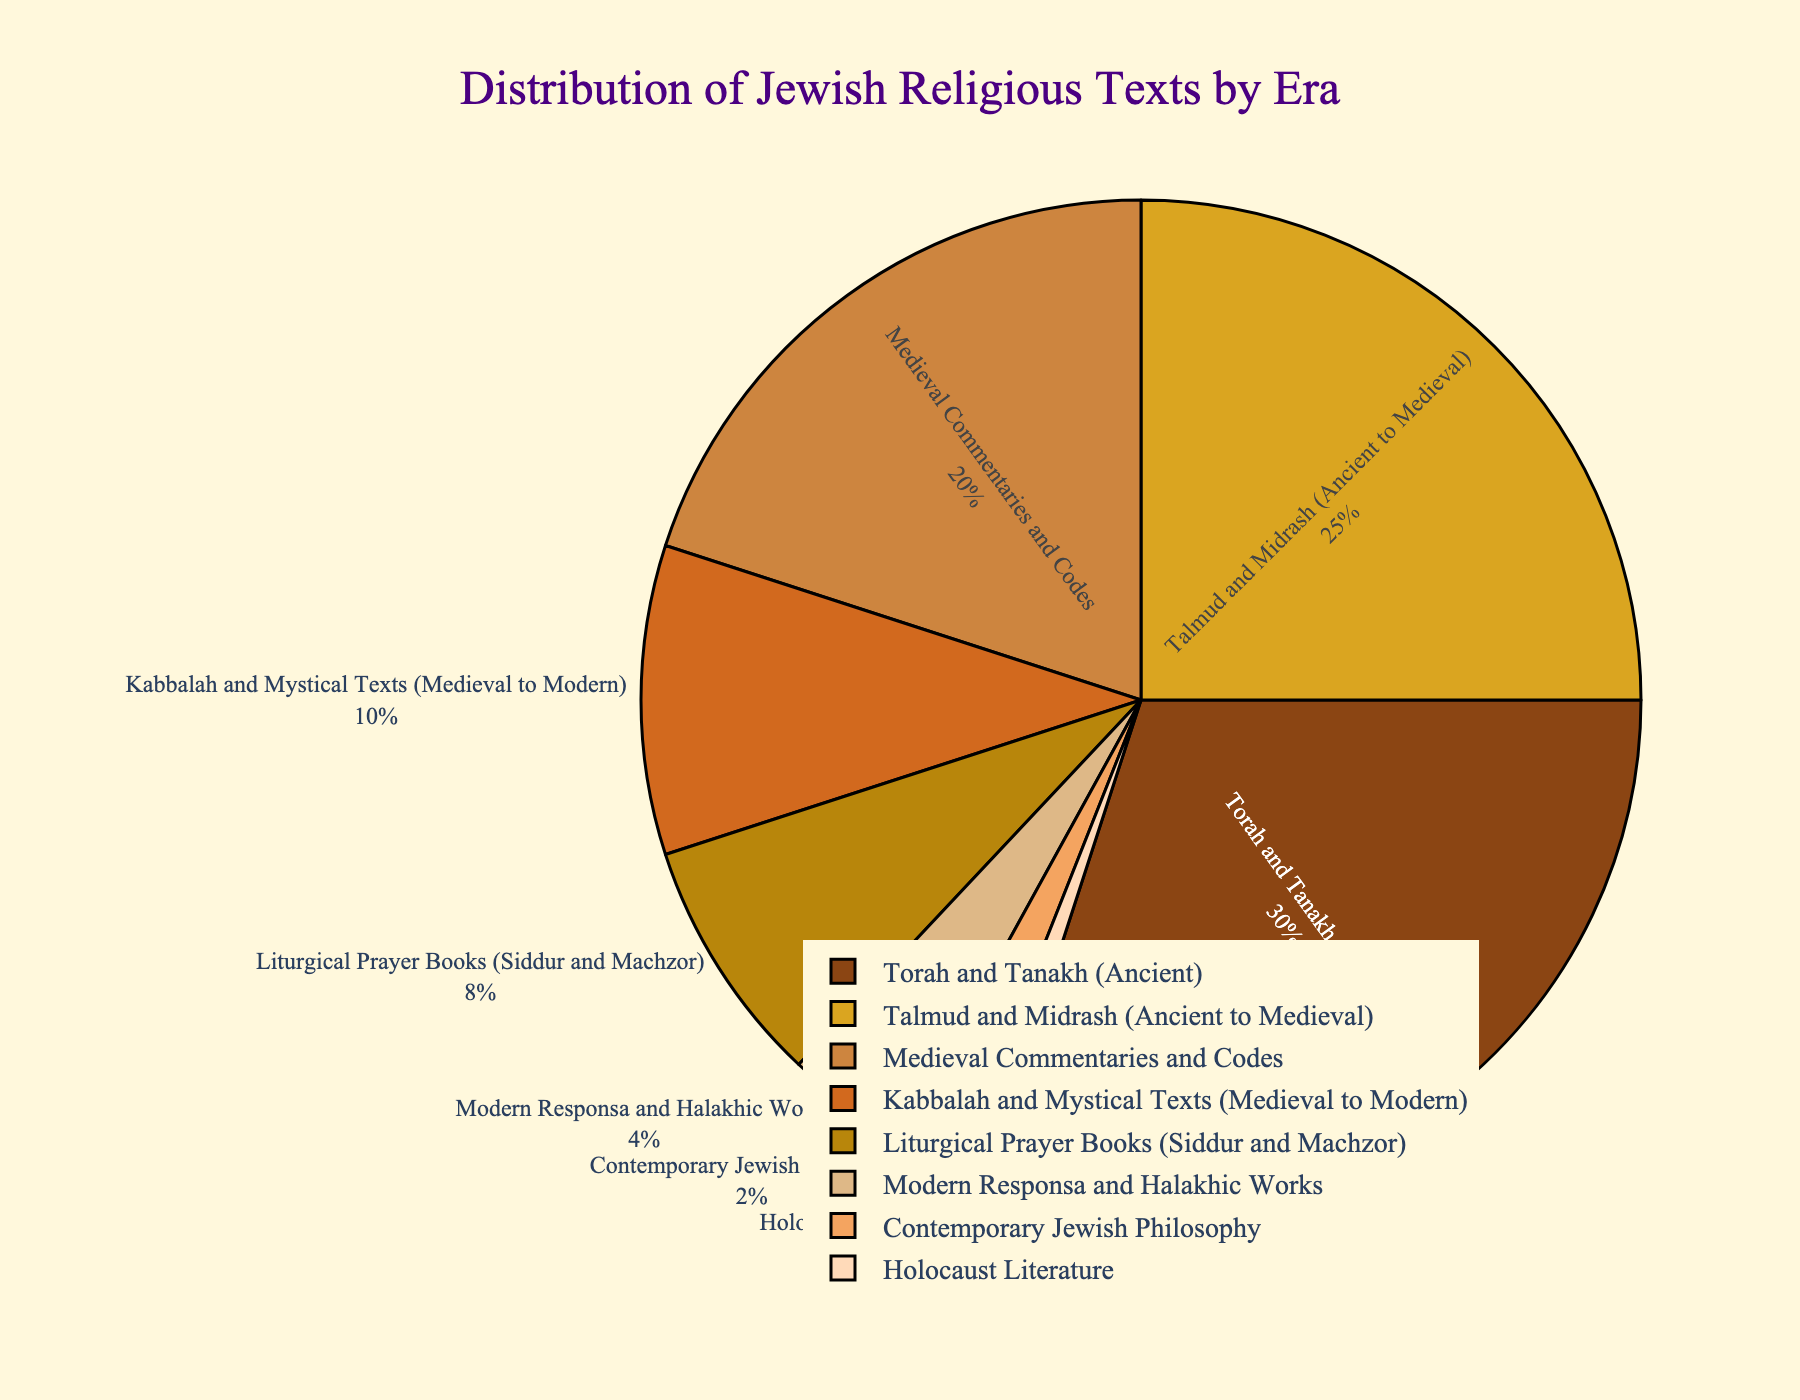Which era has the highest representation in the distribution? Look at the segment with the largest proportion in the pie chart, which is labeled as "Torah and Tanakh (Ancient)" having 30%.
Answer: Torah and Tanakh (Ancient) Which eras combined account for more than half of the distribution? Add the percentages of the largest segments one by one until the sum exceeds 50%. “Torah and Tanakh (Ancient)” is 30%, and “Talmud and Midrash (Ancient to Medieval)” is 25%. Their combined percentage is 30% + 25% = 55%.
Answer: Torah and Tanakh (Ancient) and Talmud and Midrash (Ancient to Medieval) Which era has the smallest representation in the distribution? Look at the segment with the smallest proportion in the pie chart, which is labeled "Holocaust Literature" having 1%.
Answer: Holocaust Literature What is the difference in the percentage of Medieval Commentaries and Codes compared to Modern Responsa and Halakhic Works? Find the percentage of both segments and subtract the smaller from the larger. Medieval Commentaries and Codes: 20%, Modern Responsa and Halakhic Works: 4%. Difference is 20% - 4% = 16%.
Answer: 16% Which combined percentage is higher: Kabbalah and Mystical Texts (Medieval to Modern) and Liturgical Prayer Books (Siddur and Machzor) or Modern Responsa and Halakhic Works and Contemporary Jewish Philosophy? Calculate the sums of both pairs: Kabbalah and Mystical Texts (10%) + Liturgical Prayer Books (8%) = 18%, and Modern Responsa and Halakhic Works (4%) + Contemporary Jewish Philosophy (2%) = 6%. Compare the totals, 18% is higher than 6%.
Answer: Kabbalah and Mystical Texts (Medieval to Modern) and Liturgical Prayer Books (Siddur and Machzor) Which era's segment color is the darkest brown? Visually identify the darkest brown segment in the pie chart, corresponding to the "Torah and Tanakh (Ancient)" section.
Answer: Torah and Tanakh (Ancient) Between Talmud and Midrash (Ancient to Medieval) and Kabbalah and Mystical Texts (Medieval to Modern), which has a larger representation? Compare their percentages directly. Talmud and Midrash (Ancient to Medieval) is 25% and Kabbalah and Mystical Texts (Medieval to Modern) is 10%. 25% is larger than 10%.
Answer: Talmud and Midrash (Ancient to Medieval) What percentage of texts represents Medieval and Scholarly interest (Medieval Commentaries and Codes and Kabbalah and Mystical Texts)? Sum the percentages of both segments: Medieval Commentaries and Codes (20%) + Kabbalah and Mystical Texts (10%) = 30%.
Answer: 30% If you added the percentages of Liturgical Prayer Books and Contemporary Jewish Philosophy, would their combined percentage be higher than that of Talmud and Midrash? Add the percentages of Liturgical Prayer Books (8%) and Contemporary Jewish Philosophy (2%), and compare with Talmud and Midrash (25%). 8% + 2% = 10%, which is less than 25%.
Answer: No What is the percentage of texts from the Ancient era (Torah and Tanakh, Talmud and Midrash)? Sum the percentages of Torah and Tanakh (30%) and Talmud and Midrash (25%) to get the total for Ancient era texts. 30% + 25% = 55%.
Answer: 55% 